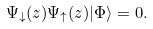Convert formula to latex. <formula><loc_0><loc_0><loc_500><loc_500>\Psi _ { \downarrow } ( z ) \Psi _ { \uparrow } ( z ) | \Phi \rangle = 0 .</formula> 